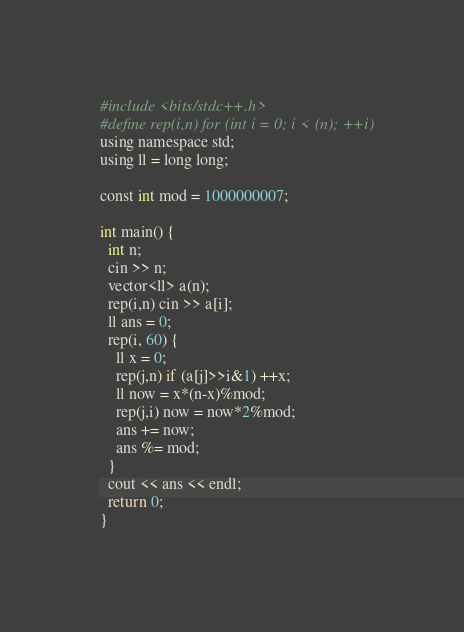<code> <loc_0><loc_0><loc_500><loc_500><_Python_>#include <bits/stdc++.h>
#define rep(i,n) for (int i = 0; i < (n); ++i)
using namespace std;
using ll = long long;

const int mod = 1000000007;

int main() {
  int n;
  cin >> n;
  vector<ll> a(n);
  rep(i,n) cin >> a[i];
  ll ans = 0;
  rep(i, 60) {
    ll x = 0;
    rep(j,n) if (a[j]>>i&1) ++x;
    ll now = x*(n-x)%mod;
    rep(j,i) now = now*2%mod;
    ans += now;
    ans %= mod;
  }
  cout << ans << endl;
  return 0;
}</code> 